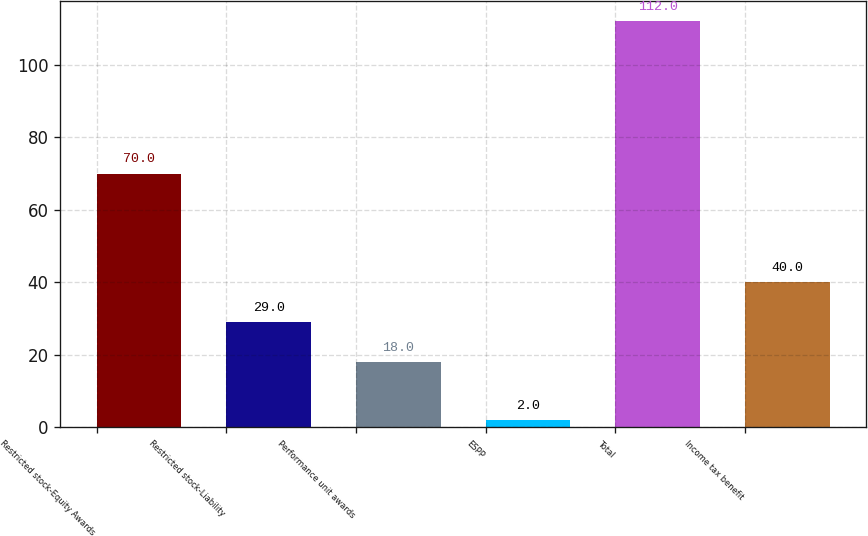Convert chart to OTSL. <chart><loc_0><loc_0><loc_500><loc_500><bar_chart><fcel>Restricted stock-Equity Awards<fcel>Restricted stock-Liability<fcel>Performance unit awards<fcel>ESPP<fcel>Total<fcel>Income tax benefit<nl><fcel>70<fcel>29<fcel>18<fcel>2<fcel>112<fcel>40<nl></chart> 